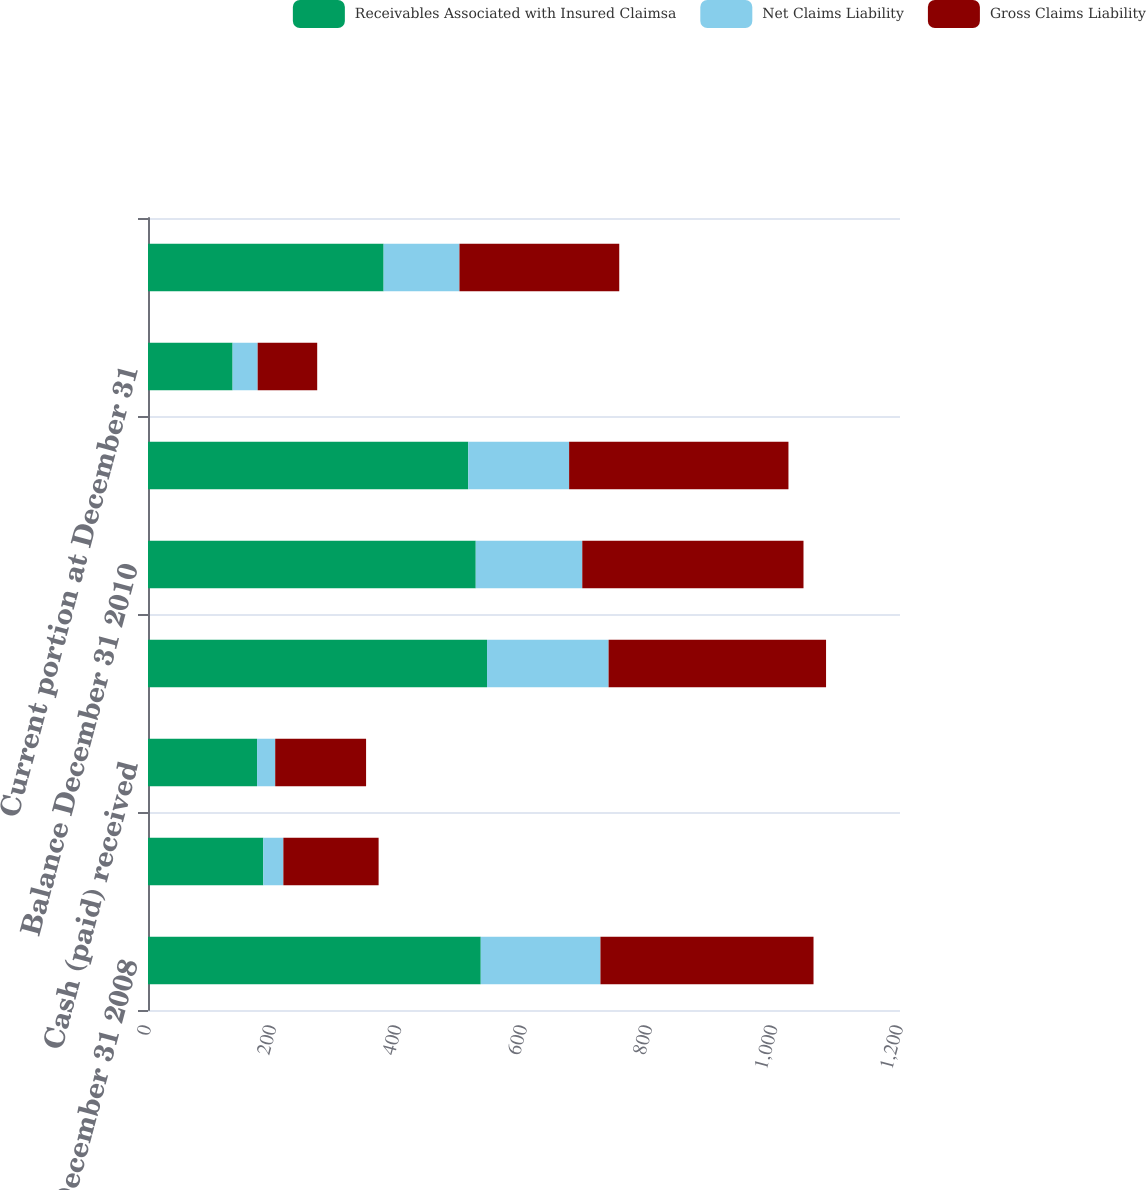<chart> <loc_0><loc_0><loc_500><loc_500><stacked_bar_chart><ecel><fcel>Balance December 31 2008<fcel>Self-insurance expense<fcel>Cash (paid) received<fcel>Balance December 31 2009<fcel>Balance December 31 2010<fcel>Balance December 31 2011(b)<fcel>Current portion at December 31<fcel>Long-term portion at December<nl><fcel>Receivables Associated with Insured Claimsa<fcel>531<fcel>184<fcel>174<fcel>541<fcel>523<fcel>511<fcel>135<fcel>376<nl><fcel>Net Claims Liability<fcel>191<fcel>32<fcel>29<fcel>194<fcel>170<fcel>161<fcel>40<fcel>121<nl><fcel>Gross Claims Liability<fcel>340<fcel>152<fcel>145<fcel>347<fcel>353<fcel>350<fcel>95<fcel>255<nl></chart> 